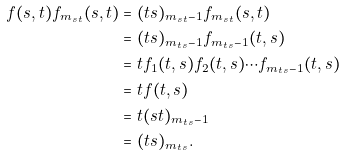<formula> <loc_0><loc_0><loc_500><loc_500>f ( s , t ) f _ { m _ { s t } } ( s , t ) & = ( t s ) _ { m _ { s t } - 1 } f _ { m _ { s t } } ( s , t ) \\ & = ( t s ) _ { m _ { t s } - 1 } f _ { m _ { t s } - 1 } ( t , s ) \\ & = t f _ { 1 } ( t , s ) f _ { 2 } ( t , s ) \cdots f _ { m _ { t s } - 1 } ( t , s ) \\ & = t f ( t , s ) \\ & = t ( s t ) _ { m _ { t s } - 1 } \\ & = ( t s ) _ { m _ { t s } } .</formula> 